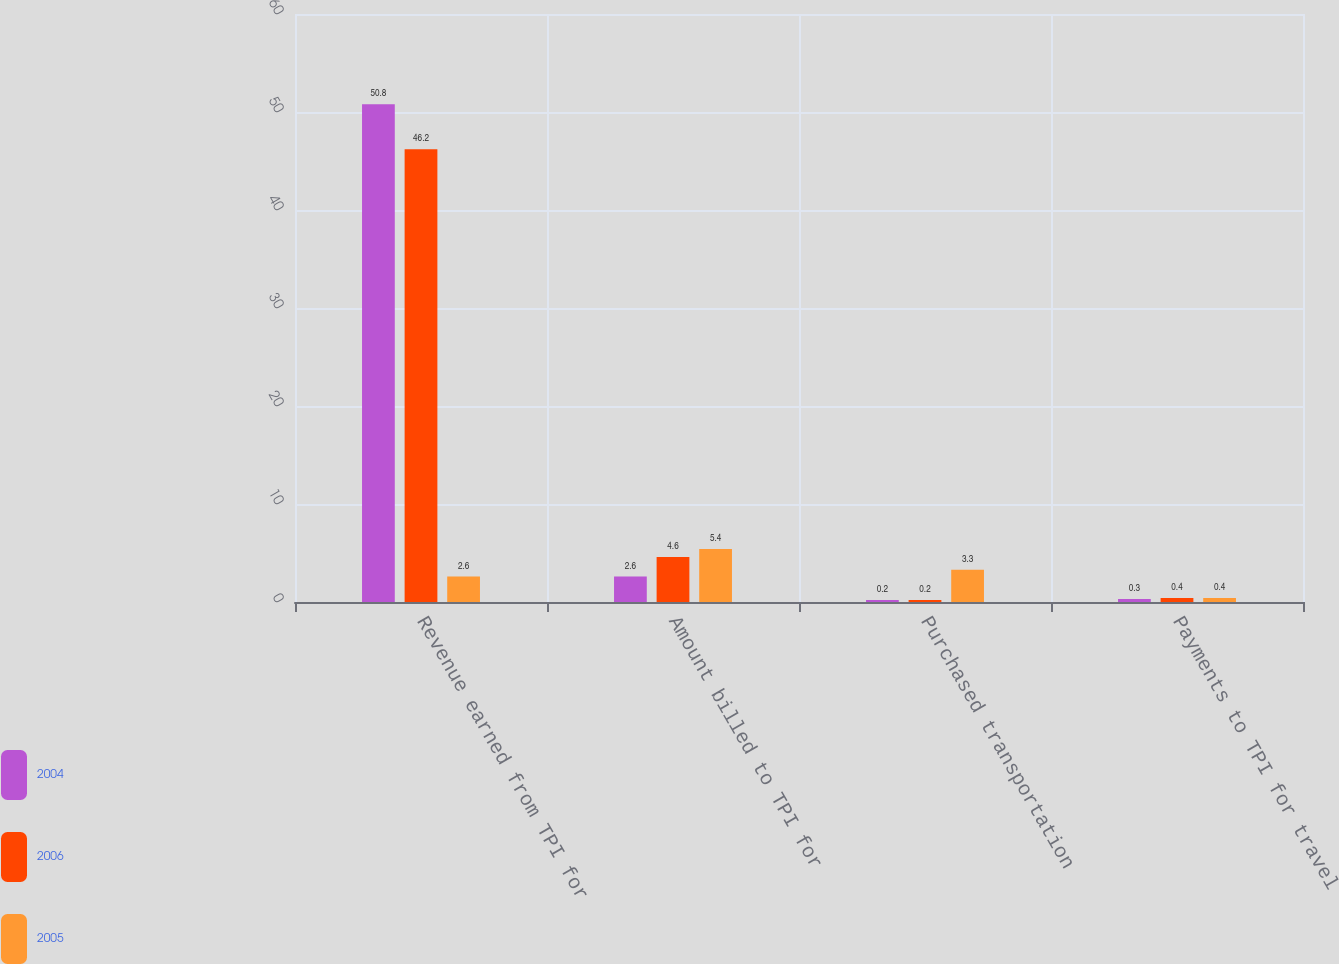Convert chart. <chart><loc_0><loc_0><loc_500><loc_500><stacked_bar_chart><ecel><fcel>Revenue earned from TPI for<fcel>Amount billed to TPI for<fcel>Purchased transportation<fcel>Payments to TPI for travel<nl><fcel>2004<fcel>50.8<fcel>2.6<fcel>0.2<fcel>0.3<nl><fcel>2006<fcel>46.2<fcel>4.6<fcel>0.2<fcel>0.4<nl><fcel>2005<fcel>2.6<fcel>5.4<fcel>3.3<fcel>0.4<nl></chart> 